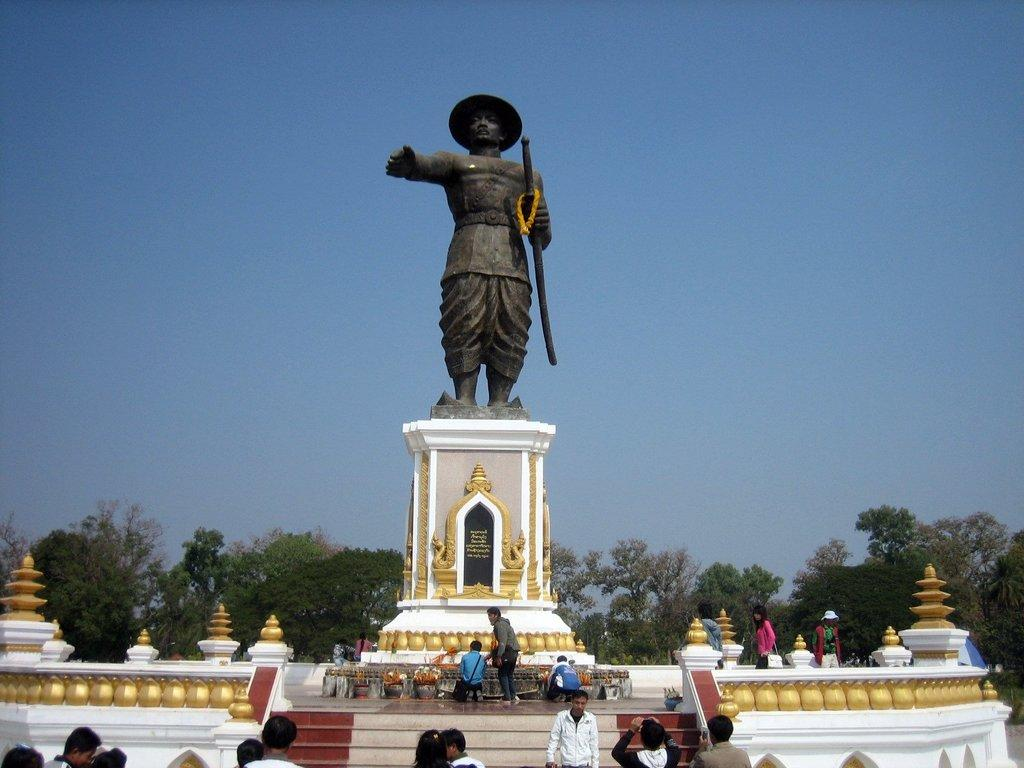Who or what can be seen in the image? There are people in the image. What architectural feature is present in the image? There are stairs in the image. What else is present in the image besides people and stairs? Musical instruments, trees, a statue, and the sky are visible in the image. What type of store can be seen in the image? There is no store present in the image. What material is the button made of in the image? There is no button present in the image. 